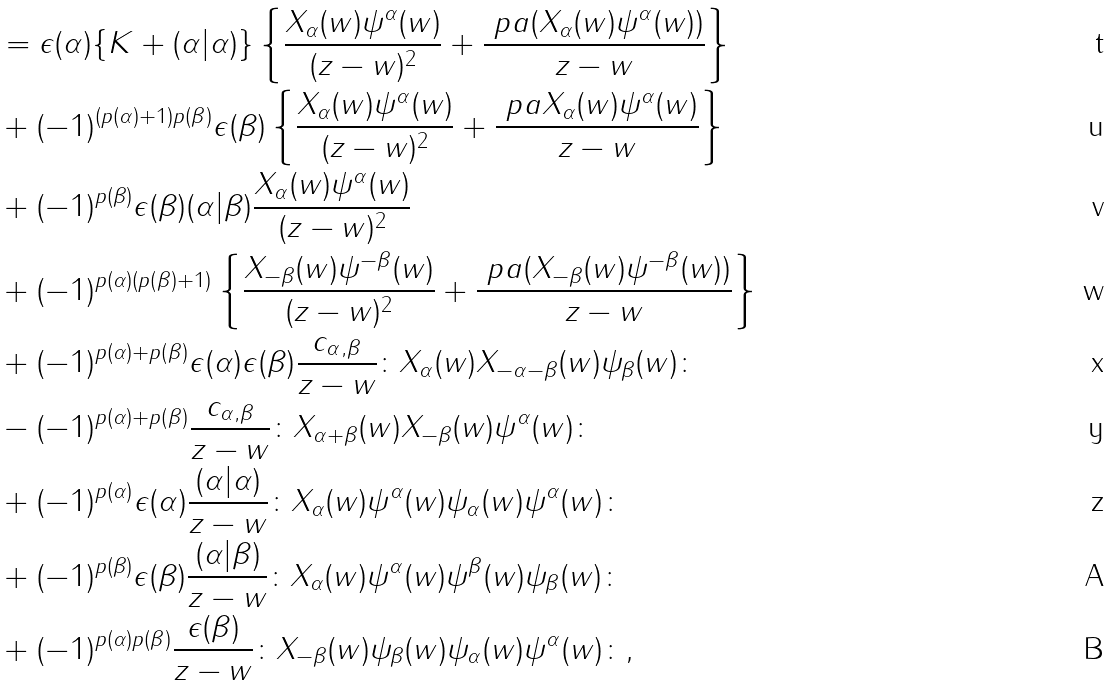Convert formula to latex. <formula><loc_0><loc_0><loc_500><loc_500>& = \epsilon ( \alpha ) \{ K + ( \alpha | \alpha ) \} \left \{ \frac { X _ { \alpha } ( w ) \psi ^ { \alpha } ( w ) } { ( z - w ) ^ { 2 } } + \frac { \ p a ( X _ { \alpha } ( w ) \psi ^ { \alpha } ( w ) ) } { z - w } \right \} \\ & + ( - 1 ) ^ { ( p ( \alpha ) + 1 ) p ( \beta ) } \epsilon ( \beta ) \left \{ \frac { X _ { \alpha } ( w ) \psi ^ { \alpha } ( w ) } { ( z - w ) ^ { 2 } } + \frac { \ p a X _ { \alpha } ( w ) \psi ^ { \alpha } ( w ) } { z - w } \right \} \\ & + ( - 1 ) ^ { p ( \beta ) } \epsilon ( \beta ) ( \alpha | \beta ) \frac { X _ { \alpha } ( w ) \psi ^ { \alpha } ( w ) } { ( z - w ) ^ { 2 } } \\ & + ( - 1 ) ^ { p ( \alpha ) ( p ( \beta ) + 1 ) } \left \{ \frac { X _ { - \beta } ( w ) \psi ^ { - \beta } ( w ) } { ( z - w ) ^ { 2 } } + \frac { \ p a ( X _ { - \beta } ( w ) \psi ^ { - \beta } ( w ) ) } { z - w } \right \} \\ & + ( - 1 ) ^ { p ( \alpha ) + p ( \beta ) } \epsilon ( \alpha ) \epsilon ( \beta ) \frac { c _ { \alpha , \beta } } { z - w } \colon X _ { \alpha } ( w ) X _ { - \alpha - \beta } ( w ) \psi _ { \beta } ( w ) \colon \\ & - ( - 1 ) ^ { p ( \alpha ) + p ( \beta ) } \frac { c _ { \alpha , \beta } } { z - w } \colon X _ { \alpha + \beta } ( w ) X _ { - \beta } ( w ) \psi ^ { \alpha } ( w ) \colon \\ & + ( - 1 ) ^ { p ( \alpha ) } \epsilon ( \alpha ) \frac { ( \alpha | \alpha ) } { z - w } \colon X _ { \alpha } ( w ) \psi ^ { \alpha } ( w ) \psi _ { \alpha } ( w ) \psi ^ { \alpha } ( w ) \colon \\ & + ( - 1 ) ^ { p ( \beta ) } \epsilon ( \beta ) \frac { ( \alpha | \beta ) } { z - w } \colon X _ { \alpha } ( w ) \psi ^ { \alpha } ( w ) \psi ^ { \beta } ( w ) \psi _ { \beta } ( w ) \colon \\ & + ( - 1 ) ^ { p ( \alpha ) p ( \beta ) } \frac { \epsilon ( \beta ) } { z - w } \colon X _ { - \beta } ( w ) \psi _ { \beta } ( w ) \psi _ { \alpha } ( w ) \psi ^ { \alpha } ( w ) \colon ,</formula> 